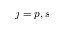<formula> <loc_0><loc_0><loc_500><loc_500>j = p , s</formula> 